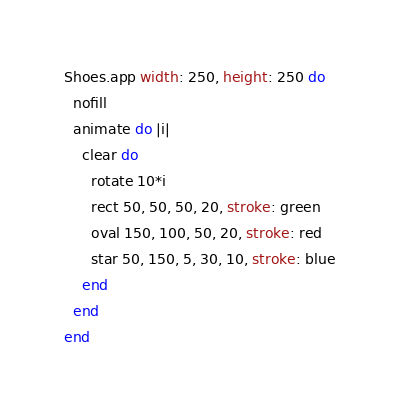<code> <loc_0><loc_0><loc_500><loc_500><_Ruby_>
Shoes.app width: 250, height: 250 do
  nofill
  animate do |i|
    clear do
      rotate 10*i
      rect 50, 50, 50, 20, stroke: green
      oval 150, 100, 50, 20, stroke: red
      star 50, 150, 5, 30, 10, stroke: blue
    end
  end
end
</code> 